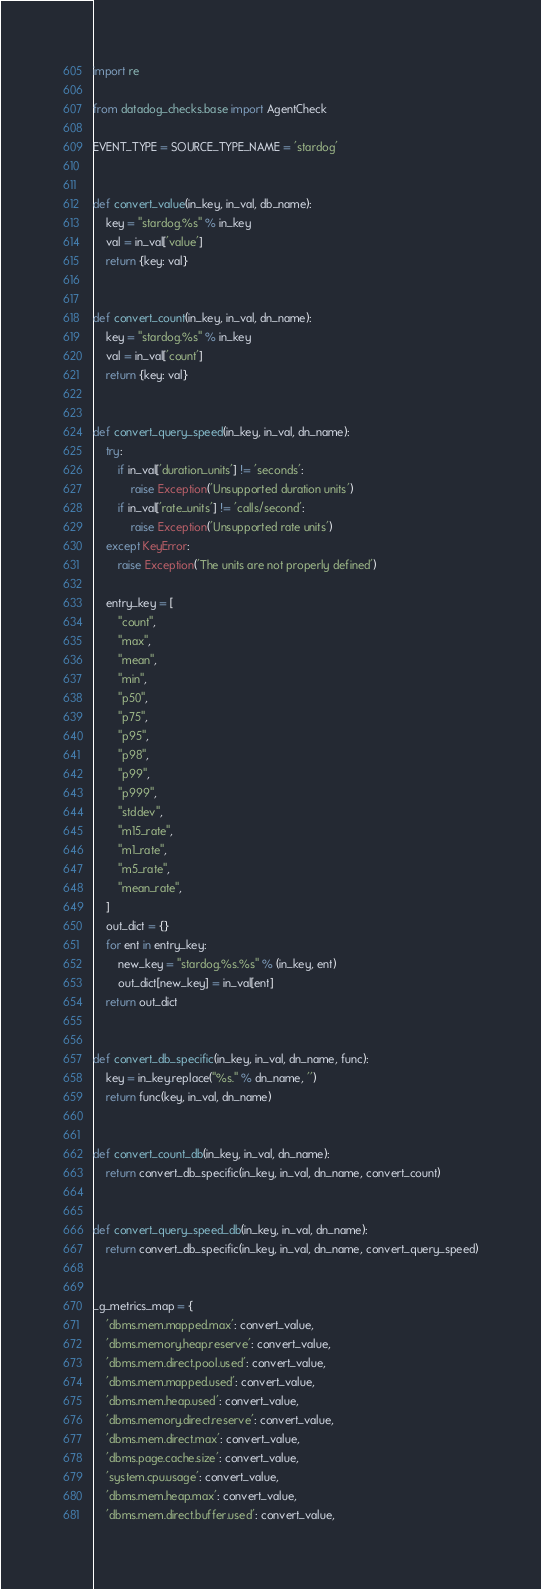Convert code to text. <code><loc_0><loc_0><loc_500><loc_500><_Python_>import re

from datadog_checks.base import AgentCheck

EVENT_TYPE = SOURCE_TYPE_NAME = 'stardog'


def convert_value(in_key, in_val, db_name):
    key = "stardog.%s" % in_key
    val = in_val['value']
    return {key: val}


def convert_count(in_key, in_val, dn_name):
    key = "stardog.%s" % in_key
    val = in_val['count']
    return {key: val}


def convert_query_speed(in_key, in_val, dn_name):
    try:
        if in_val['duration_units'] != 'seconds':
            raise Exception('Unsupported duration units')
        if in_val['rate_units'] != 'calls/second':
            raise Exception('Unsupported rate units')
    except KeyError:
        raise Exception('The units are not properly defined')

    entry_key = [
        "count",
        "max",
        "mean",
        "min",
        "p50",
        "p75",
        "p95",
        "p98",
        "p99",
        "p999",
        "stddev",
        "m15_rate",
        "m1_rate",
        "m5_rate",
        "mean_rate",
    ]
    out_dict = {}
    for ent in entry_key:
        new_key = "stardog.%s.%s" % (in_key, ent)
        out_dict[new_key] = in_val[ent]
    return out_dict


def convert_db_specific(in_key, in_val, dn_name, func):
    key = in_key.replace("%s." % dn_name, '')
    return func(key, in_val, dn_name)


def convert_count_db(in_key, in_val, dn_name):
    return convert_db_specific(in_key, in_val, dn_name, convert_count)


def convert_query_speed_db(in_key, in_val, dn_name):
    return convert_db_specific(in_key, in_val, dn_name, convert_query_speed)


_g_metrics_map = {
    'dbms.mem.mapped.max': convert_value,
    'dbms.memory.heap.reserve': convert_value,
    'dbms.mem.direct.pool.used': convert_value,
    'dbms.mem.mapped.used': convert_value,
    'dbms.mem.heap.used': convert_value,
    'dbms.memory.direct.reserve': convert_value,
    'dbms.mem.direct.max': convert_value,
    'dbms.page.cache.size': convert_value,
    'system.cpu.usage': convert_value,
    'dbms.mem.heap.max': convert_value,
    'dbms.mem.direct.buffer.used': convert_value,</code> 